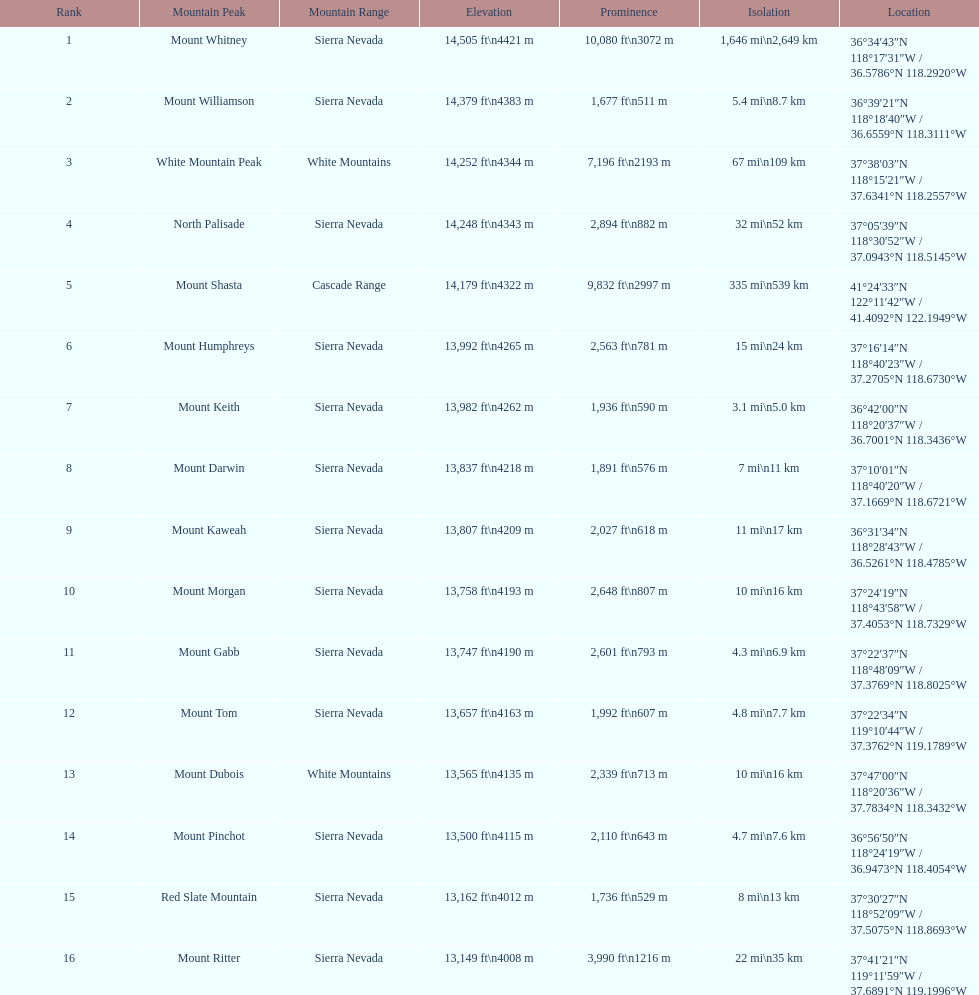Which mountain is higher, mount humphreys or mount kaweah? Mount Humphreys. 